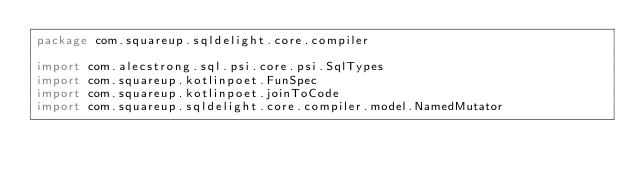Convert code to text. <code><loc_0><loc_0><loc_500><loc_500><_Kotlin_>package com.squareup.sqldelight.core.compiler

import com.alecstrong.sql.psi.core.psi.SqlTypes
import com.squareup.kotlinpoet.FunSpec
import com.squareup.kotlinpoet.joinToCode
import com.squareup.sqldelight.core.compiler.model.NamedMutator</code> 